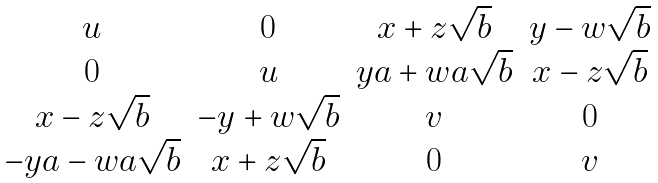Convert formula to latex. <formula><loc_0><loc_0><loc_500><loc_500>\begin{matrix} u & 0 & x + z \sqrt { b } & y - w \sqrt { b } \\ 0 & u & y a + w a \sqrt { b } & x - z \sqrt { b } \\ x - z \sqrt { b } & - y + w \sqrt { b } & v & 0 \\ - y a - w a \sqrt { b } & x + z \sqrt { b } & 0 & v \end{matrix}</formula> 